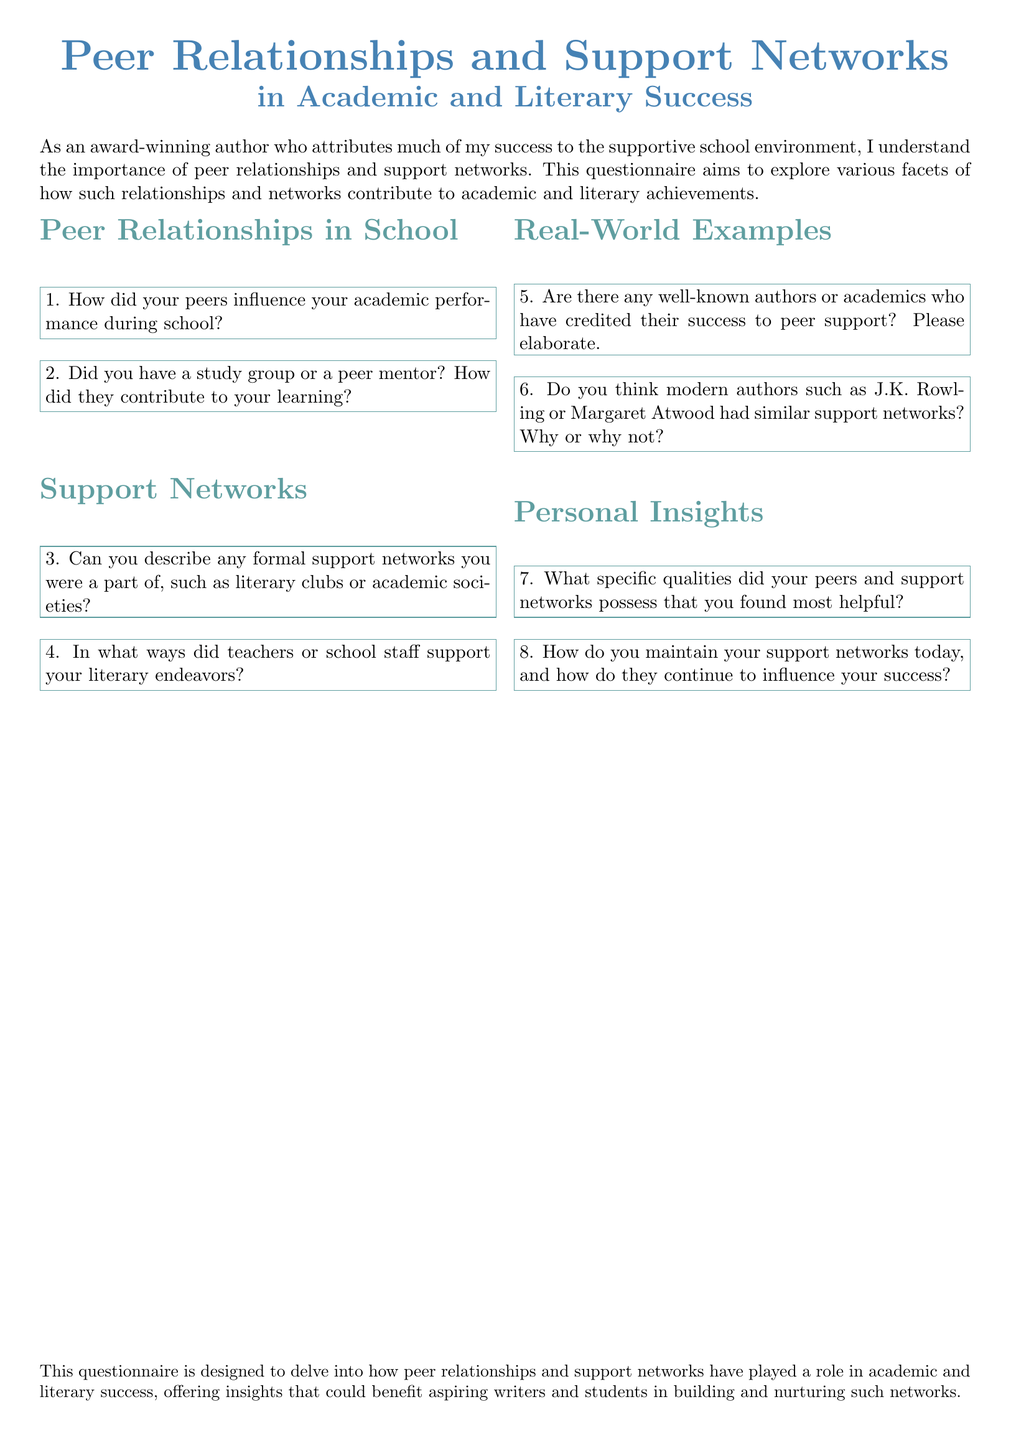What is the title of the document? The title of the document is presented at the top of the rendered document and emphasizes peer relationships and support networks.
Answer: Peer Relationships and Support Networks in Academic and Literary Success How many sections are there in the questionnaire? The document contains four distinct sections regarding peer relationships and support networks.
Answer: Four What question asks about peer influence? The first question seeks to understand how peers influenced academic performance during school.
Answer: How did your peers influence your academic performance during school? Which type of support networks does the document mention? The document refers to formal support networks such as literary clubs or academic societies in one of its questions.
Answer: Literary clubs or academic societies Who are two modern authors mentioned in the questionnaire? The questionnaire references J.K. Rowling and Margaret Atwood in the context of support networks.
Answer: J.K. Rowling, Margaret Atwood What is the focus of the Personal Insights section? This section aims to gather information about the qualities of peers and support networks and their ongoing influence on success.
Answer: Qualities of peers and support networks 